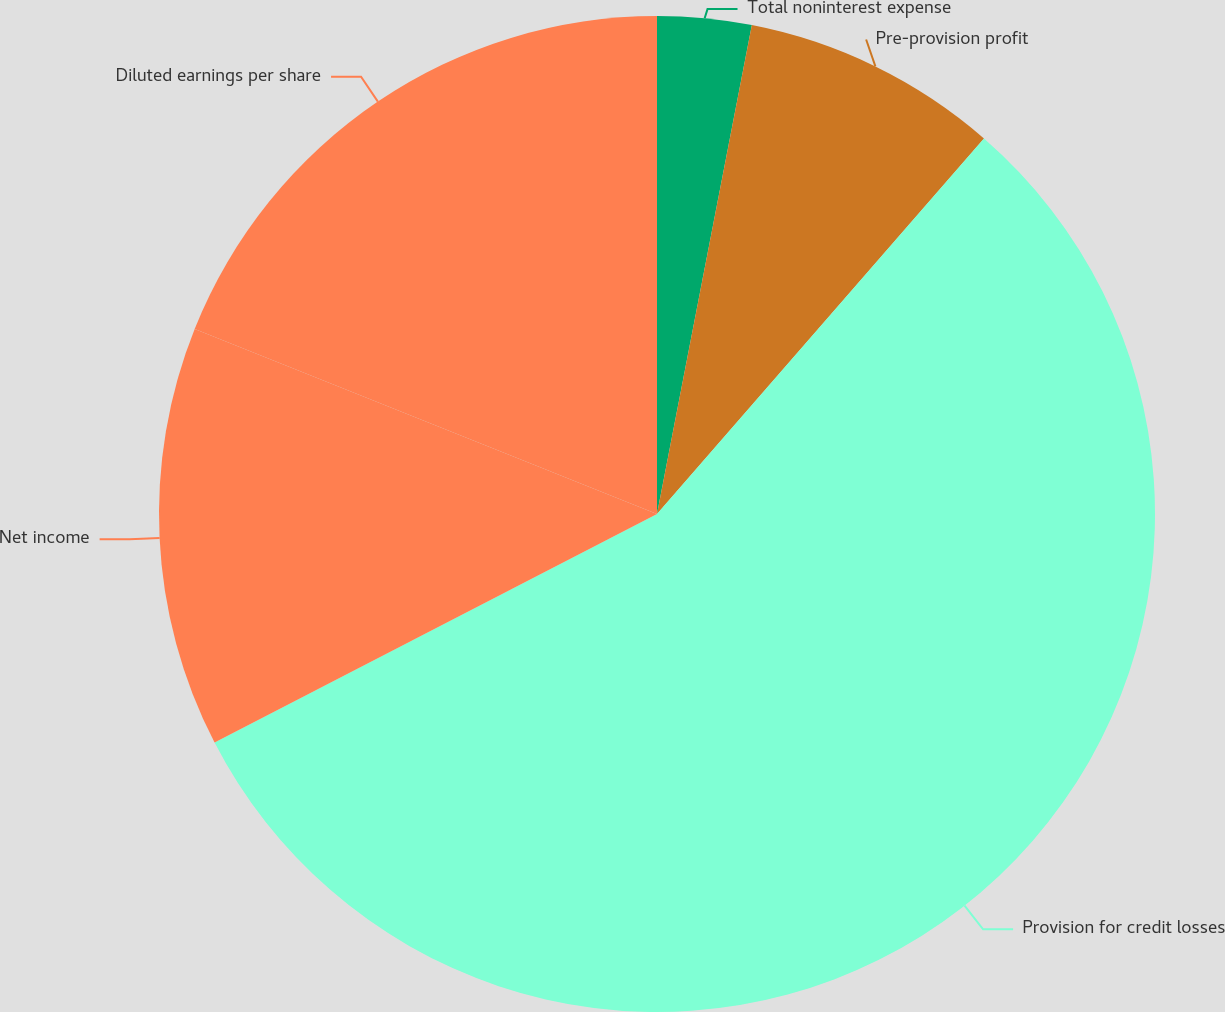Convert chart to OTSL. <chart><loc_0><loc_0><loc_500><loc_500><pie_chart><fcel>Total noninterest expense<fcel>Pre-provision profit<fcel>Provision for credit losses<fcel>Net income<fcel>Diluted earnings per share<nl><fcel>3.05%<fcel>8.35%<fcel>56.01%<fcel>13.65%<fcel>18.94%<nl></chart> 